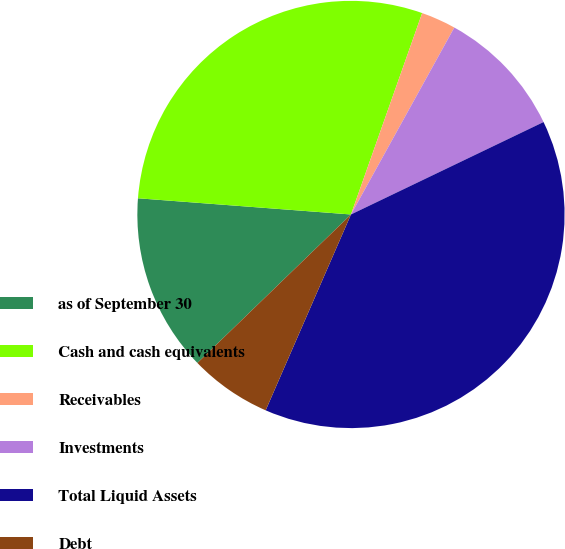Convert chart. <chart><loc_0><loc_0><loc_500><loc_500><pie_chart><fcel>as of September 30<fcel>Cash and cash equivalents<fcel>Receivables<fcel>Investments<fcel>Total Liquid Assets<fcel>Debt<nl><fcel>13.44%<fcel>29.2%<fcel>2.63%<fcel>9.84%<fcel>38.66%<fcel>6.23%<nl></chart> 